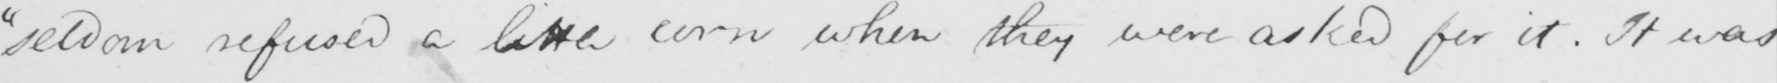Can you tell me what this handwritten text says? "seldom refused a live corn when they were asked for it. It was 